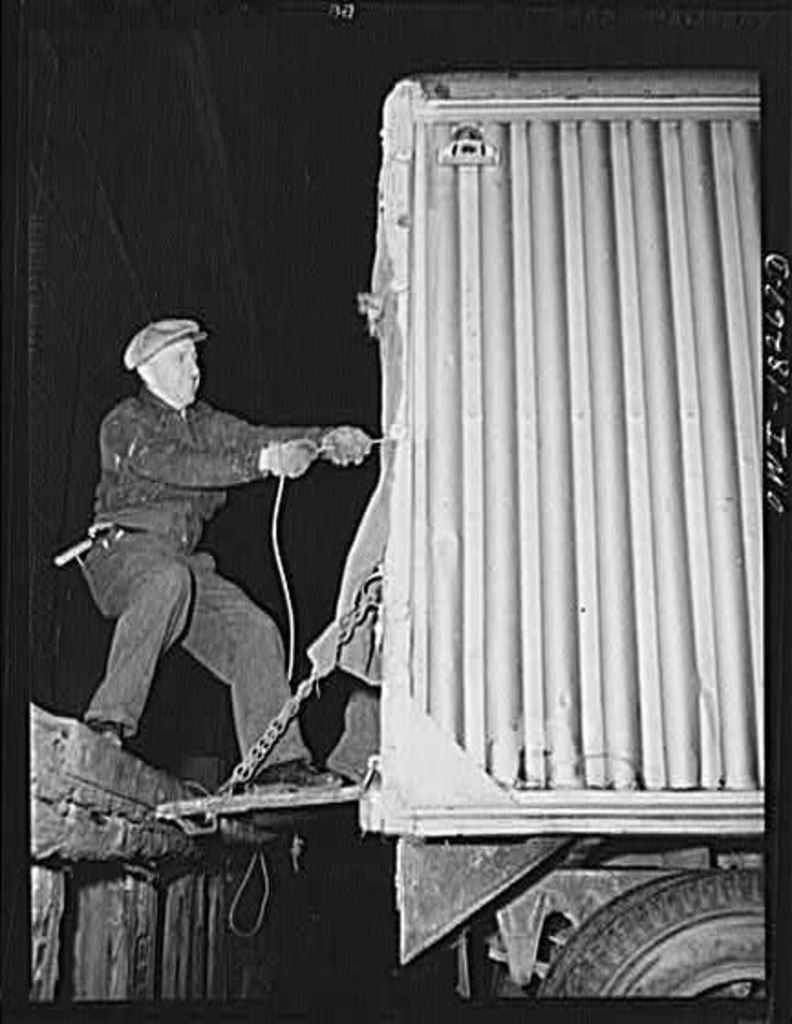What is the main subject in the image? There is a vehicle in the image. What is the person in the image doing? A person is pulling an object in the image. How many sheep are present in the image? There are no sheep present in the image. What type of connection is visible between the person and the object they are pulling? The image does not provide enough information to determine the type of connection between the person and the object they are pulling. 